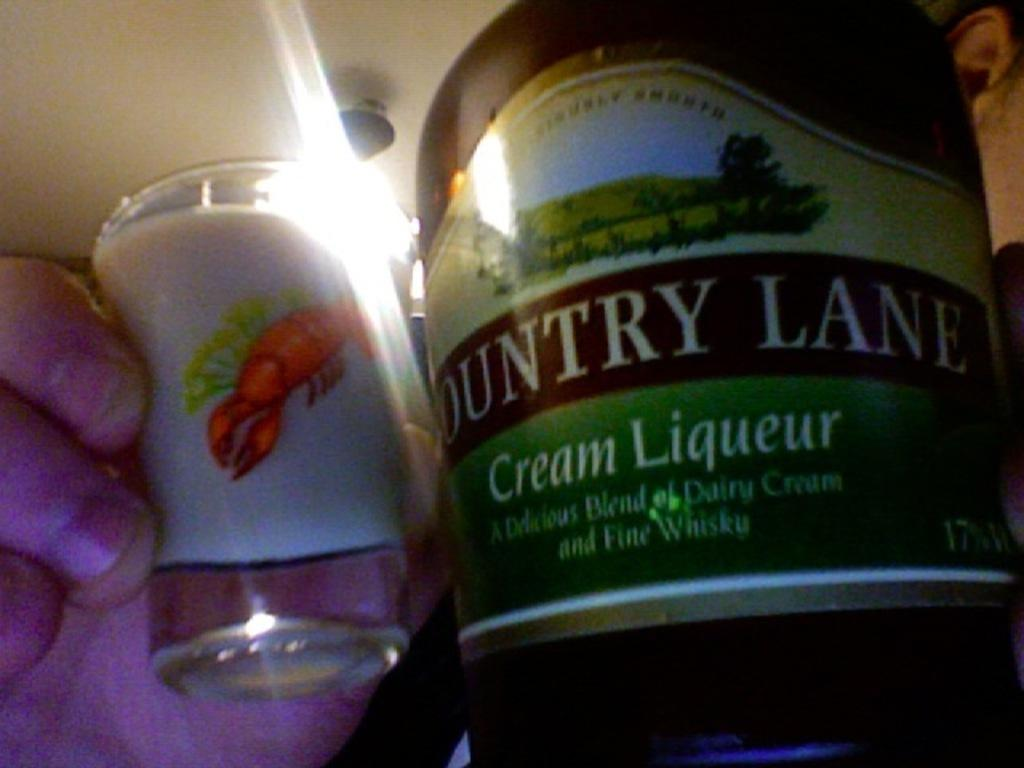<image>
Write a terse but informative summary of the picture. The bottle of Cream Liqueur in made by County Lane. 